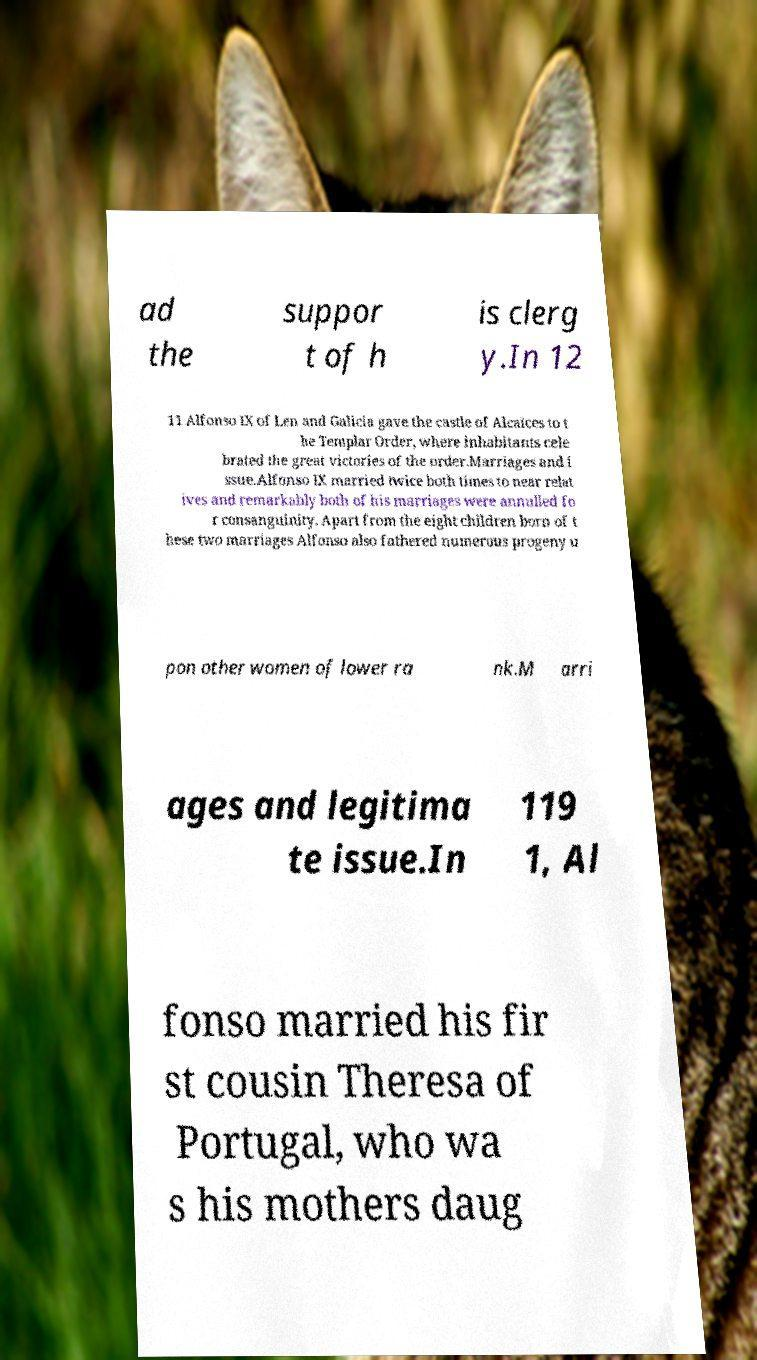Can you read and provide the text displayed in the image?This photo seems to have some interesting text. Can you extract and type it out for me? ad the suppor t of h is clerg y.In 12 11 Alfonso IX of Len and Galicia gave the castle of Alcaices to t he Templar Order, where inhabitants cele brated the great victories of the order.Marriages and i ssue.Alfonso IX married twice both times to near relat ives and remarkably both of his marriages were annulled fo r consanguinity. Apart from the eight children born of t hese two marriages Alfonso also fathered numerous progeny u pon other women of lower ra nk.M arri ages and legitima te issue.In 119 1, Al fonso married his fir st cousin Theresa of Portugal, who wa s his mothers daug 